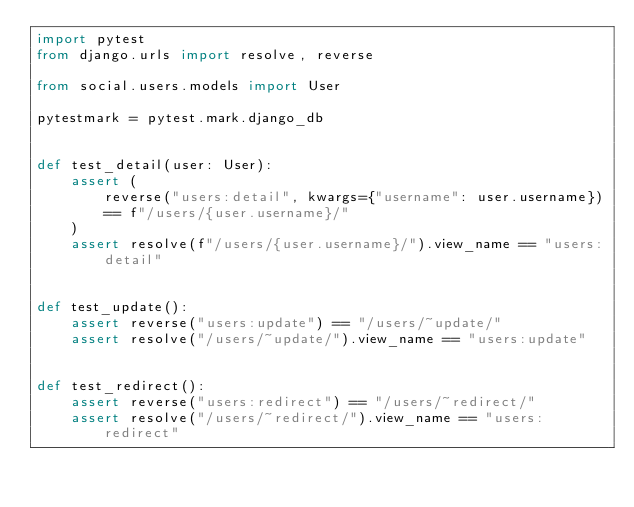Convert code to text. <code><loc_0><loc_0><loc_500><loc_500><_Python_>import pytest
from django.urls import resolve, reverse

from social.users.models import User

pytestmark = pytest.mark.django_db


def test_detail(user: User):
    assert (
        reverse("users:detail", kwargs={"username": user.username})
        == f"/users/{user.username}/"
    )
    assert resolve(f"/users/{user.username}/").view_name == "users:detail"


def test_update():
    assert reverse("users:update") == "/users/~update/"
    assert resolve("/users/~update/").view_name == "users:update"


def test_redirect():
    assert reverse("users:redirect") == "/users/~redirect/"
    assert resolve("/users/~redirect/").view_name == "users:redirect"
</code> 